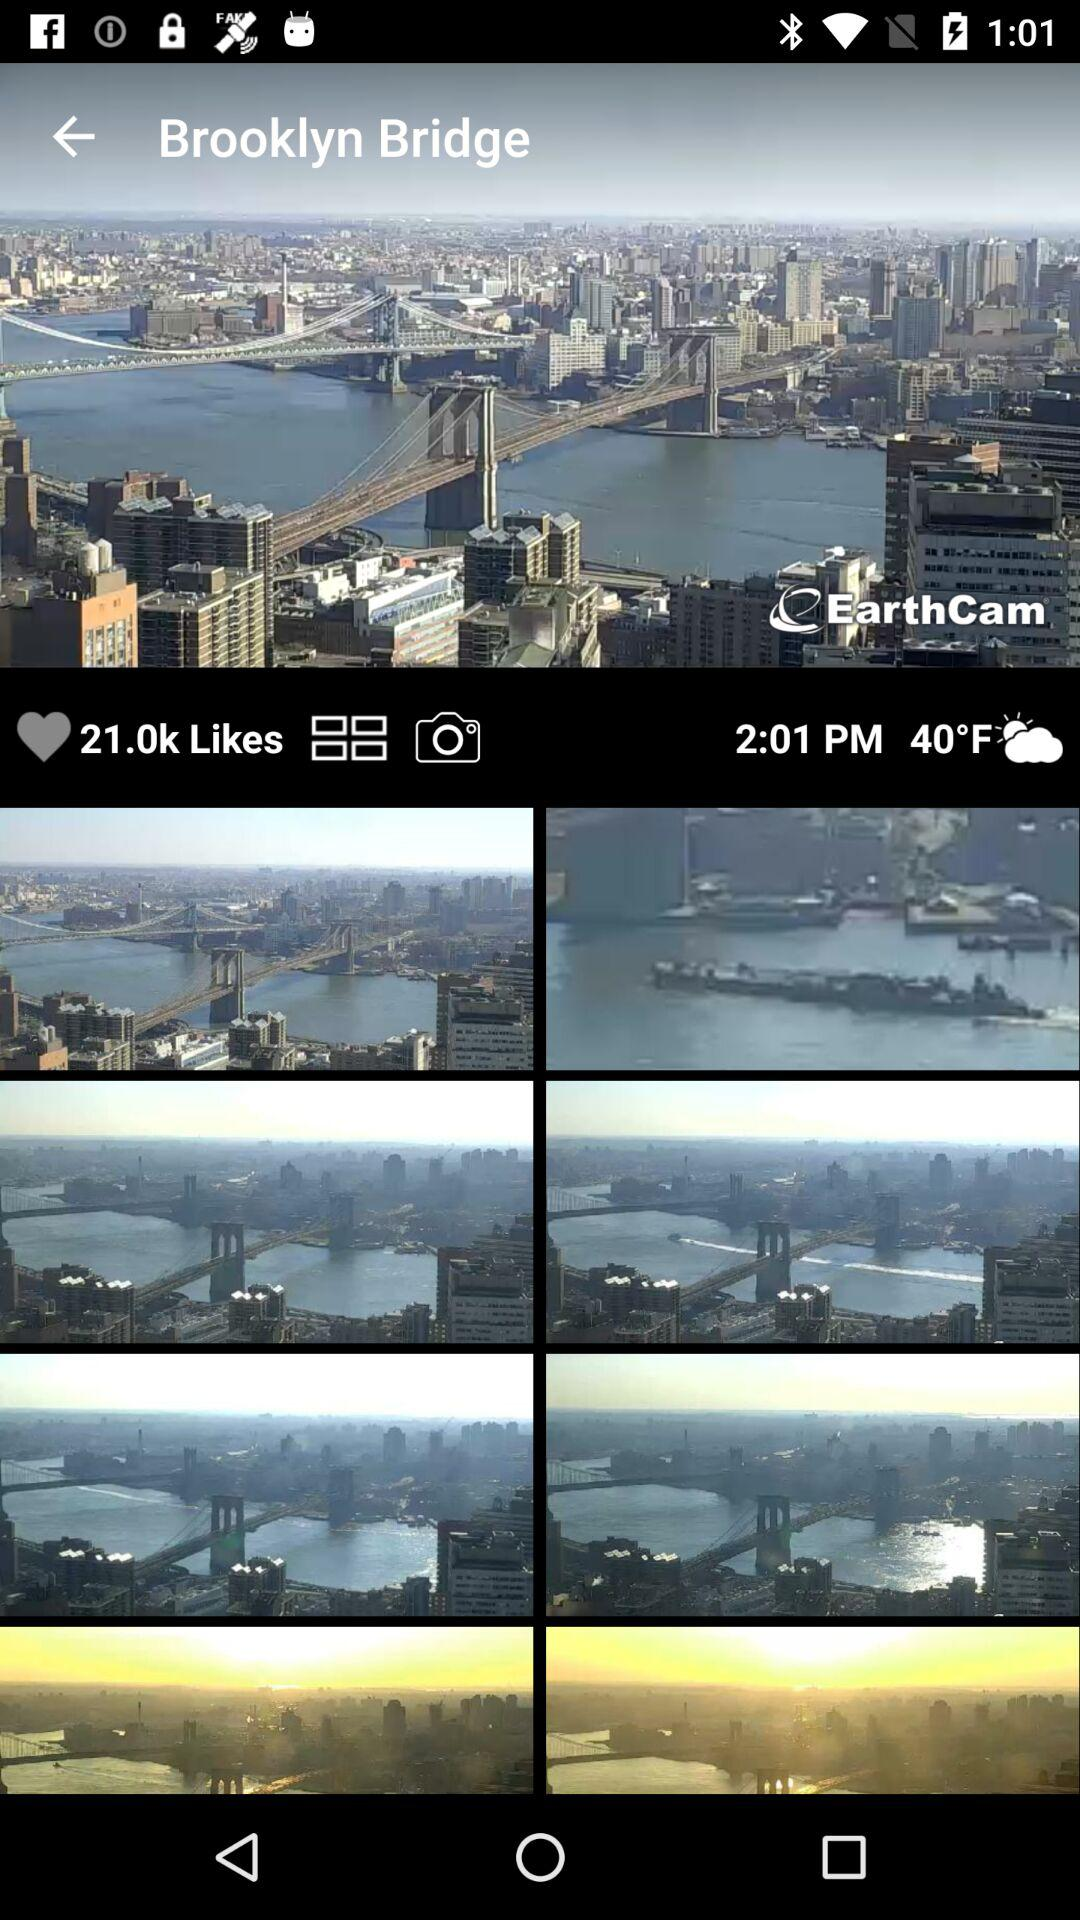What is the mentioned time? The mentioned time is 2:01 PM. 